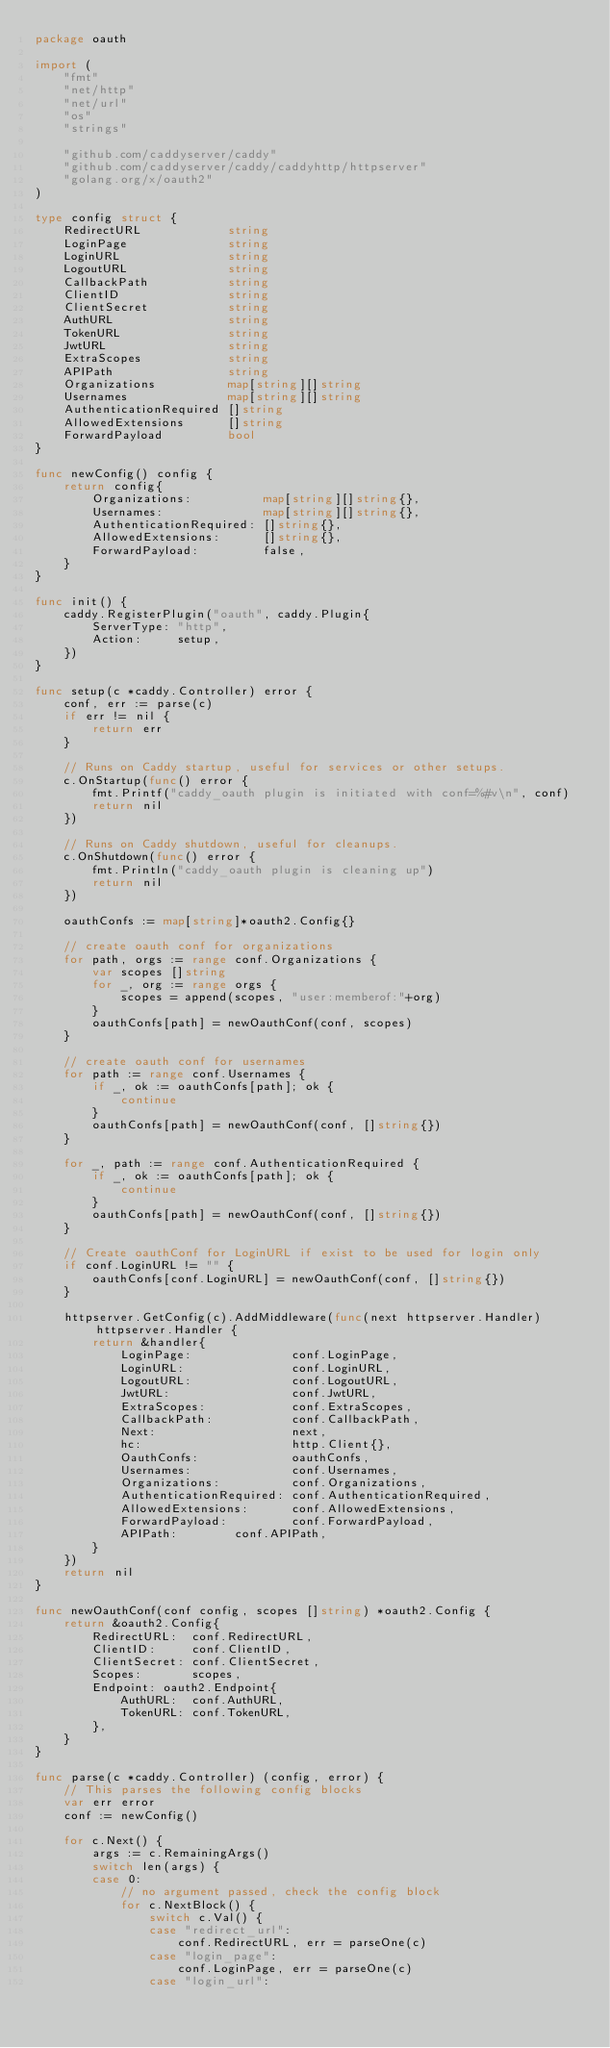Convert code to text. <code><loc_0><loc_0><loc_500><loc_500><_Go_>package oauth

import (
	"fmt"
	"net/http"
	"net/url"
	"os"
	"strings"

	"github.com/caddyserver/caddy"
	"github.com/caddyserver/caddy/caddyhttp/httpserver"
	"golang.org/x/oauth2"
)

type config struct {
	RedirectURL            string
	LoginPage              string
	LoginURL               string
	LogoutURL              string
	CallbackPath           string
	ClientID               string
	ClientSecret           string
	AuthURL                string
	TokenURL               string
	JwtURL                 string
	ExtraScopes            string
	APIPath                string
	Organizations          map[string][]string
	Usernames              map[string][]string
	AuthenticationRequired []string
	AllowedExtensions      []string
	ForwardPayload         bool
}

func newConfig() config {
	return config{
		Organizations:          map[string][]string{},
		Usernames:              map[string][]string{},
		AuthenticationRequired: []string{},
		AllowedExtensions:      []string{},
		ForwardPayload:         false,
	}
}

func init() {
	caddy.RegisterPlugin("oauth", caddy.Plugin{
		ServerType: "http",
		Action:     setup,
	})
}

func setup(c *caddy.Controller) error {
	conf, err := parse(c)
	if err != nil {
		return err
	}

	// Runs on Caddy startup, useful for services or other setups.
	c.OnStartup(func() error {
		fmt.Printf("caddy_oauth plugin is initiated with conf=%#v\n", conf)
		return nil
	})

	// Runs on Caddy shutdown, useful for cleanups.
	c.OnShutdown(func() error {
		fmt.Println("caddy_oauth plugin is cleaning up")
		return nil
	})

	oauthConfs := map[string]*oauth2.Config{}

	// create oauth conf for organizations
	for path, orgs := range conf.Organizations {
		var scopes []string
		for _, org := range orgs {
			scopes = append(scopes, "user:memberof:"+org)
		}
		oauthConfs[path] = newOauthConf(conf, scopes)
	}

	// create oauth conf for usernames
	for path := range conf.Usernames {
		if _, ok := oauthConfs[path]; ok {
			continue
		}
		oauthConfs[path] = newOauthConf(conf, []string{})
	}

	for _, path := range conf.AuthenticationRequired {
		if _, ok := oauthConfs[path]; ok {
			continue
		}
		oauthConfs[path] = newOauthConf(conf, []string{})
	}

	// Create oauthConf for LoginURL if exist to be used for login only
	if conf.LoginURL != "" {
		oauthConfs[conf.LoginURL] = newOauthConf(conf, []string{})
	}

	httpserver.GetConfig(c).AddMiddleware(func(next httpserver.Handler) httpserver.Handler {
		return &handler{
			LoginPage:              conf.LoginPage,
			LoginURL:               conf.LoginURL,
			LogoutURL:              conf.LogoutURL,
			JwtURL:                 conf.JwtURL,
			ExtraScopes:            conf.ExtraScopes,
			CallbackPath:           conf.CallbackPath,
			Next:                   next,
			hc:                     http.Client{},
			OauthConfs:             oauthConfs,
			Usernames:              conf.Usernames,
			Organizations:          conf.Organizations,
			AuthenticationRequired: conf.AuthenticationRequired,
			AllowedExtensions:      conf.AllowedExtensions,
			ForwardPayload:         conf.ForwardPayload,
			APIPath: 		conf.APIPath,
		}
	})
	return nil
}

func newOauthConf(conf config, scopes []string) *oauth2.Config {
	return &oauth2.Config{
		RedirectURL:  conf.RedirectURL,
		ClientID:     conf.ClientID,
		ClientSecret: conf.ClientSecret,
		Scopes:       scopes,
		Endpoint: oauth2.Endpoint{
			AuthURL:  conf.AuthURL,
			TokenURL: conf.TokenURL,
		},
	}
}

func parse(c *caddy.Controller) (config, error) {
	// This parses the following config blocks
	var err error
	conf := newConfig()

	for c.Next() {
		args := c.RemainingArgs()
		switch len(args) {
		case 0:
			// no argument passed, check the config block
			for c.NextBlock() {
				switch c.Val() {
				case "redirect_url":
					conf.RedirectURL, err = parseOne(c)
				case "login_page":
					conf.LoginPage, err = parseOne(c)
				case "login_url":</code> 